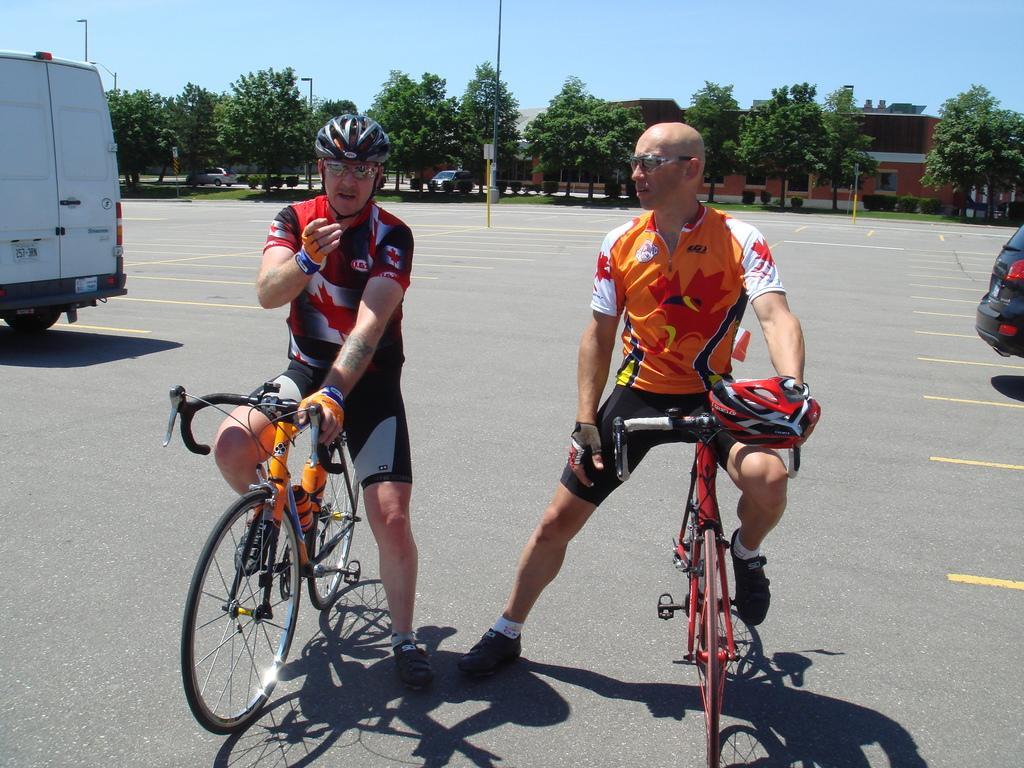Can you describe this image briefly? In this image I can see two men are sitting on their cycles. I can see both of them are wearing shades and one is wearing a helmet. I can see another one is holding his helmet. In the background I can see few vehicles, few trees, buildings and sky. 